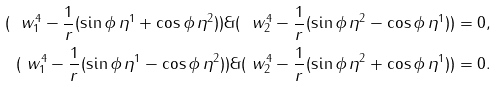<formula> <loc_0><loc_0><loc_500><loc_500>( \ w ^ { 4 } _ { 1 } - \frac { 1 } { r } ( \sin \phi \, \eta ^ { 1 } + \cos \phi \, \eta ^ { 2 } ) ) \& ( \ w ^ { 4 } _ { 2 } - \frac { 1 } { r } ( \sin \phi \, \eta ^ { 2 } - \cos \phi \, \eta ^ { 1 } ) ) & = 0 , \\ ( \ w ^ { 4 } _ { 1 } - \frac { 1 } { r } ( \sin \phi \, \eta ^ { 1 } - \cos \phi \, \eta ^ { 2 } ) ) \& ( \ w ^ { 4 } _ { 2 } - \frac { 1 } { r } ( \sin \phi \, \eta ^ { 2 } + \cos \phi \, \eta ^ { 1 } ) ) & = 0 .</formula> 